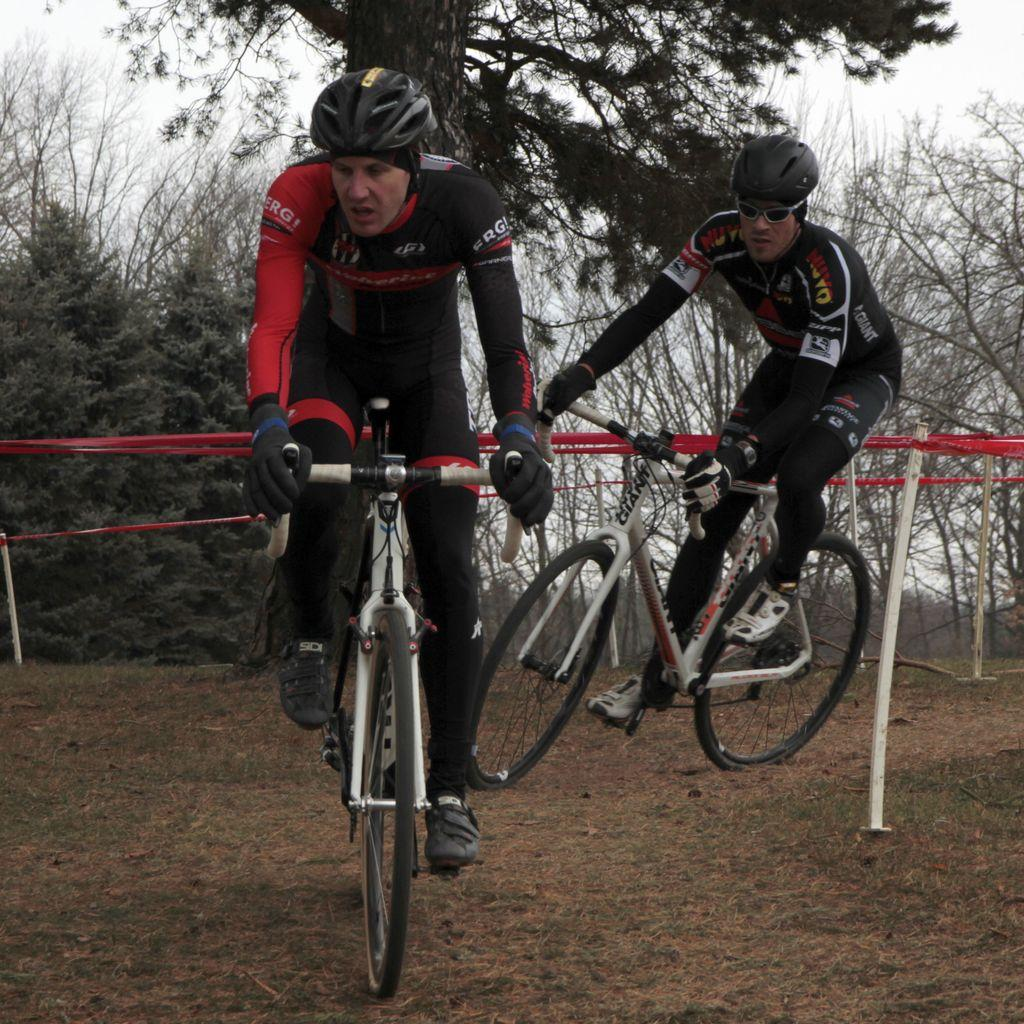How many people are in the image? There are two people in the image. What are the people doing in the image? The people are riding bicycles. What can be seen on the path in the image? There are red color tapes and stands on the path. What is visible in the background of the image? Trees are visible in the background of the image. What type of locket is the carpenter holding while riding a plane in the image? There is no carpenter, locket, or plane present in the image. 